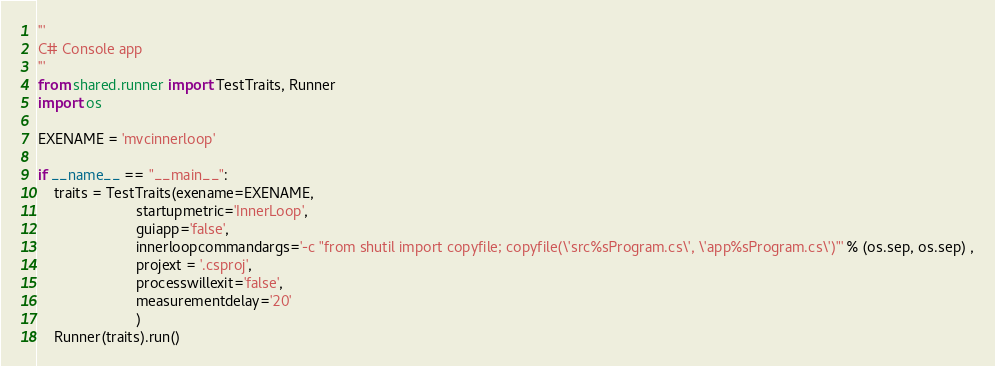Convert code to text. <code><loc_0><loc_0><loc_500><loc_500><_Python_>'''
C# Console app
'''
from shared.runner import TestTraits, Runner
import os

EXENAME = 'mvcinnerloop'

if __name__ == "__main__":
    traits = TestTraits(exename=EXENAME, 
                        startupmetric='InnerLoop',
                        guiapp='false',
                        innerloopcommandargs='-c "from shutil import copyfile; copyfile(\'src%sProgram.cs\', \'app%sProgram.cs\')"' % (os.sep, os.sep) ,
                        projext = '.csproj',
                        processwillexit='false',
                        measurementdelay='20'
                        )
    Runner(traits).run()
</code> 